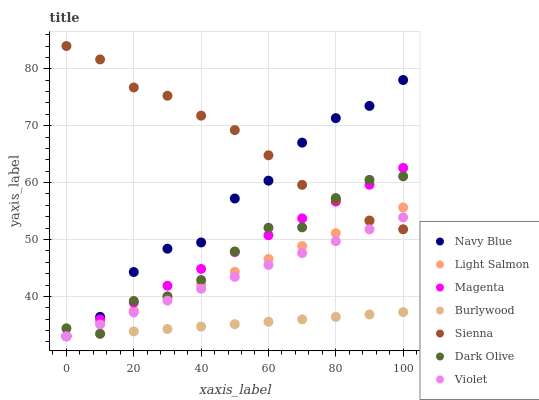Does Burlywood have the minimum area under the curve?
Answer yes or no. Yes. Does Sienna have the maximum area under the curve?
Answer yes or no. Yes. Does Navy Blue have the minimum area under the curve?
Answer yes or no. No. Does Navy Blue have the maximum area under the curve?
Answer yes or no. No. Is Light Salmon the smoothest?
Answer yes or no. Yes. Is Navy Blue the roughest?
Answer yes or no. Yes. Is Navy Blue the smoothest?
Answer yes or no. No. Is Burlywood the roughest?
Answer yes or no. No. Does Light Salmon have the lowest value?
Answer yes or no. Yes. Does Dark Olive have the lowest value?
Answer yes or no. No. Does Sienna have the highest value?
Answer yes or no. Yes. Does Navy Blue have the highest value?
Answer yes or no. No. Is Burlywood less than Sienna?
Answer yes or no. Yes. Is Sienna greater than Burlywood?
Answer yes or no. Yes. Does Navy Blue intersect Burlywood?
Answer yes or no. Yes. Is Navy Blue less than Burlywood?
Answer yes or no. No. Is Navy Blue greater than Burlywood?
Answer yes or no. No. Does Burlywood intersect Sienna?
Answer yes or no. No. 